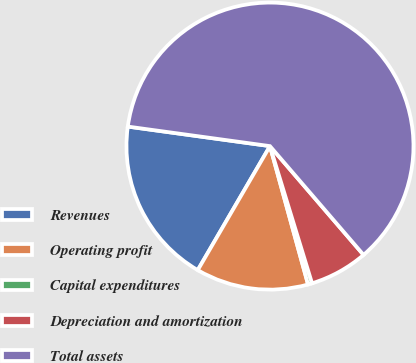<chart> <loc_0><loc_0><loc_500><loc_500><pie_chart><fcel>Revenues<fcel>Operating profit<fcel>Capital expenditures<fcel>Depreciation and amortization<fcel>Total assets<nl><fcel>18.78%<fcel>12.67%<fcel>0.46%<fcel>6.57%<fcel>61.52%<nl></chart> 